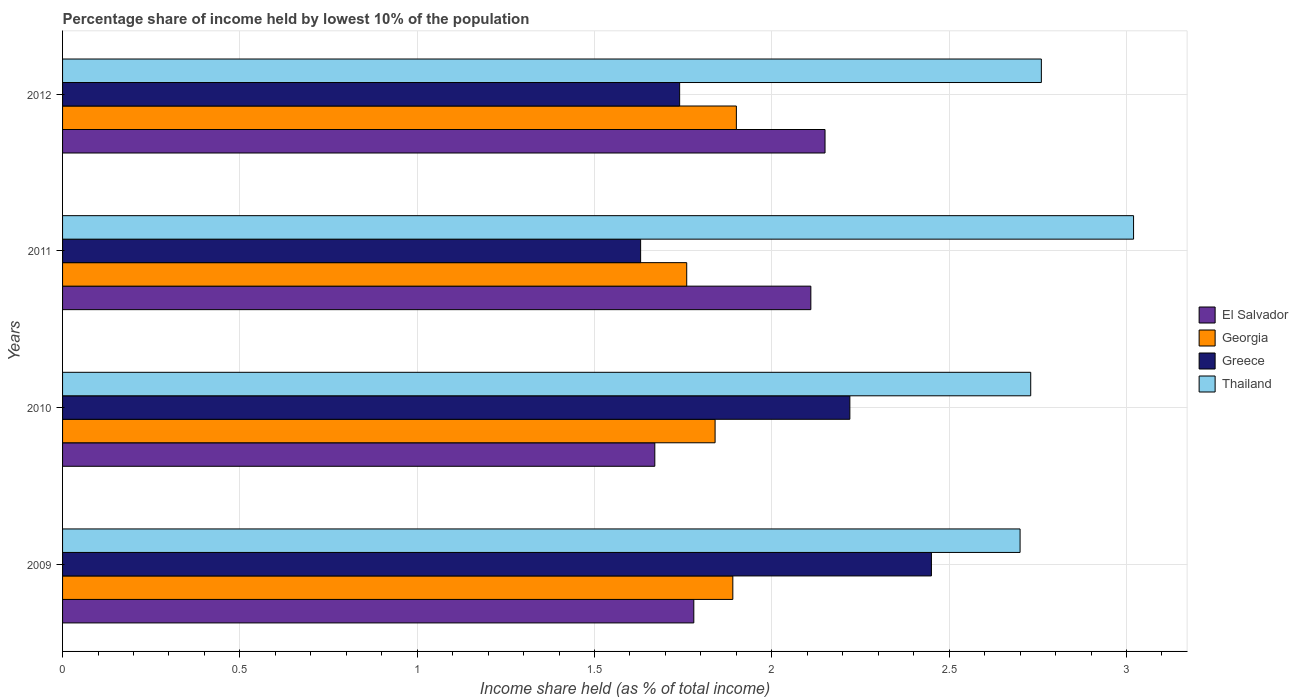How many groups of bars are there?
Your response must be concise. 4. Are the number of bars per tick equal to the number of legend labels?
Ensure brevity in your answer.  Yes. How many bars are there on the 1st tick from the top?
Offer a very short reply. 4. How many bars are there on the 4th tick from the bottom?
Offer a terse response. 4. In how many cases, is the number of bars for a given year not equal to the number of legend labels?
Give a very brief answer. 0. What is the percentage share of income held by lowest 10% of the population in Georgia in 2012?
Give a very brief answer. 1.9. Across all years, what is the maximum percentage share of income held by lowest 10% of the population in Thailand?
Offer a very short reply. 3.02. Across all years, what is the minimum percentage share of income held by lowest 10% of the population in Georgia?
Provide a succinct answer. 1.76. In which year was the percentage share of income held by lowest 10% of the population in Thailand maximum?
Your answer should be very brief. 2011. What is the total percentage share of income held by lowest 10% of the population in Greece in the graph?
Provide a succinct answer. 8.04. What is the difference between the percentage share of income held by lowest 10% of the population in Georgia in 2010 and that in 2012?
Your answer should be compact. -0.06. What is the difference between the percentage share of income held by lowest 10% of the population in Georgia in 2010 and the percentage share of income held by lowest 10% of the population in Thailand in 2009?
Offer a very short reply. -0.86. What is the average percentage share of income held by lowest 10% of the population in Georgia per year?
Keep it short and to the point. 1.85. In the year 2010, what is the difference between the percentage share of income held by lowest 10% of the population in Greece and percentage share of income held by lowest 10% of the population in El Salvador?
Ensure brevity in your answer.  0.55. In how many years, is the percentage share of income held by lowest 10% of the population in Georgia greater than 0.7 %?
Give a very brief answer. 4. What is the ratio of the percentage share of income held by lowest 10% of the population in Thailand in 2010 to that in 2011?
Your answer should be very brief. 0.9. Is the percentage share of income held by lowest 10% of the population in El Salvador in 2009 less than that in 2011?
Offer a very short reply. Yes. Is the difference between the percentage share of income held by lowest 10% of the population in Greece in 2011 and 2012 greater than the difference between the percentage share of income held by lowest 10% of the population in El Salvador in 2011 and 2012?
Provide a succinct answer. No. What is the difference between the highest and the second highest percentage share of income held by lowest 10% of the population in Georgia?
Make the answer very short. 0.01. What is the difference between the highest and the lowest percentage share of income held by lowest 10% of the population in Greece?
Your answer should be compact. 0.82. Is the sum of the percentage share of income held by lowest 10% of the population in Thailand in 2009 and 2011 greater than the maximum percentage share of income held by lowest 10% of the population in El Salvador across all years?
Your answer should be compact. Yes. What does the 4th bar from the top in 2011 represents?
Give a very brief answer. El Salvador. What does the 3rd bar from the bottom in 2012 represents?
Your answer should be very brief. Greece. What is the difference between two consecutive major ticks on the X-axis?
Provide a short and direct response. 0.5. Are the values on the major ticks of X-axis written in scientific E-notation?
Make the answer very short. No. Does the graph contain any zero values?
Provide a succinct answer. No. Does the graph contain grids?
Provide a short and direct response. Yes. Where does the legend appear in the graph?
Offer a terse response. Center right. How are the legend labels stacked?
Your response must be concise. Vertical. What is the title of the graph?
Provide a succinct answer. Percentage share of income held by lowest 10% of the population. Does "Kazakhstan" appear as one of the legend labels in the graph?
Offer a terse response. No. What is the label or title of the X-axis?
Ensure brevity in your answer.  Income share held (as % of total income). What is the Income share held (as % of total income) in El Salvador in 2009?
Give a very brief answer. 1.78. What is the Income share held (as % of total income) of Georgia in 2009?
Your answer should be very brief. 1.89. What is the Income share held (as % of total income) of Greece in 2009?
Your answer should be compact. 2.45. What is the Income share held (as % of total income) of Thailand in 2009?
Offer a very short reply. 2.7. What is the Income share held (as % of total income) in El Salvador in 2010?
Offer a terse response. 1.67. What is the Income share held (as % of total income) of Georgia in 2010?
Give a very brief answer. 1.84. What is the Income share held (as % of total income) of Greece in 2010?
Offer a terse response. 2.22. What is the Income share held (as % of total income) in Thailand in 2010?
Make the answer very short. 2.73. What is the Income share held (as % of total income) in El Salvador in 2011?
Provide a short and direct response. 2.11. What is the Income share held (as % of total income) in Georgia in 2011?
Your response must be concise. 1.76. What is the Income share held (as % of total income) of Greece in 2011?
Provide a succinct answer. 1.63. What is the Income share held (as % of total income) in Thailand in 2011?
Your response must be concise. 3.02. What is the Income share held (as % of total income) in El Salvador in 2012?
Ensure brevity in your answer.  2.15. What is the Income share held (as % of total income) of Georgia in 2012?
Your answer should be very brief. 1.9. What is the Income share held (as % of total income) in Greece in 2012?
Offer a very short reply. 1.74. What is the Income share held (as % of total income) in Thailand in 2012?
Your answer should be very brief. 2.76. Across all years, what is the maximum Income share held (as % of total income) in El Salvador?
Offer a terse response. 2.15. Across all years, what is the maximum Income share held (as % of total income) of Greece?
Provide a short and direct response. 2.45. Across all years, what is the maximum Income share held (as % of total income) in Thailand?
Your response must be concise. 3.02. Across all years, what is the minimum Income share held (as % of total income) of El Salvador?
Ensure brevity in your answer.  1.67. Across all years, what is the minimum Income share held (as % of total income) in Georgia?
Your answer should be compact. 1.76. Across all years, what is the minimum Income share held (as % of total income) of Greece?
Offer a terse response. 1.63. What is the total Income share held (as % of total income) in El Salvador in the graph?
Offer a terse response. 7.71. What is the total Income share held (as % of total income) of Georgia in the graph?
Offer a very short reply. 7.39. What is the total Income share held (as % of total income) of Greece in the graph?
Provide a short and direct response. 8.04. What is the total Income share held (as % of total income) in Thailand in the graph?
Your response must be concise. 11.21. What is the difference between the Income share held (as % of total income) of El Salvador in 2009 and that in 2010?
Give a very brief answer. 0.11. What is the difference between the Income share held (as % of total income) in Greece in 2009 and that in 2010?
Give a very brief answer. 0.23. What is the difference between the Income share held (as % of total income) in Thailand in 2009 and that in 2010?
Provide a short and direct response. -0.03. What is the difference between the Income share held (as % of total income) in El Salvador in 2009 and that in 2011?
Your answer should be very brief. -0.33. What is the difference between the Income share held (as % of total income) in Georgia in 2009 and that in 2011?
Your answer should be compact. 0.13. What is the difference between the Income share held (as % of total income) in Greece in 2009 and that in 2011?
Provide a short and direct response. 0.82. What is the difference between the Income share held (as % of total income) in Thailand in 2009 and that in 2011?
Provide a short and direct response. -0.32. What is the difference between the Income share held (as % of total income) in El Salvador in 2009 and that in 2012?
Offer a terse response. -0.37. What is the difference between the Income share held (as % of total income) of Georgia in 2009 and that in 2012?
Make the answer very short. -0.01. What is the difference between the Income share held (as % of total income) in Greece in 2009 and that in 2012?
Your answer should be compact. 0.71. What is the difference between the Income share held (as % of total income) in Thailand in 2009 and that in 2012?
Your answer should be very brief. -0.06. What is the difference between the Income share held (as % of total income) of El Salvador in 2010 and that in 2011?
Offer a terse response. -0.44. What is the difference between the Income share held (as % of total income) of Georgia in 2010 and that in 2011?
Keep it short and to the point. 0.08. What is the difference between the Income share held (as % of total income) in Greece in 2010 and that in 2011?
Give a very brief answer. 0.59. What is the difference between the Income share held (as % of total income) of Thailand in 2010 and that in 2011?
Make the answer very short. -0.29. What is the difference between the Income share held (as % of total income) of El Salvador in 2010 and that in 2012?
Your response must be concise. -0.48. What is the difference between the Income share held (as % of total income) in Georgia in 2010 and that in 2012?
Offer a terse response. -0.06. What is the difference between the Income share held (as % of total income) in Greece in 2010 and that in 2012?
Offer a terse response. 0.48. What is the difference between the Income share held (as % of total income) of Thailand in 2010 and that in 2012?
Your response must be concise. -0.03. What is the difference between the Income share held (as % of total income) of El Salvador in 2011 and that in 2012?
Offer a very short reply. -0.04. What is the difference between the Income share held (as % of total income) in Georgia in 2011 and that in 2012?
Make the answer very short. -0.14. What is the difference between the Income share held (as % of total income) in Greece in 2011 and that in 2012?
Provide a short and direct response. -0.11. What is the difference between the Income share held (as % of total income) of Thailand in 2011 and that in 2012?
Your answer should be very brief. 0.26. What is the difference between the Income share held (as % of total income) in El Salvador in 2009 and the Income share held (as % of total income) in Georgia in 2010?
Your response must be concise. -0.06. What is the difference between the Income share held (as % of total income) in El Salvador in 2009 and the Income share held (as % of total income) in Greece in 2010?
Offer a terse response. -0.44. What is the difference between the Income share held (as % of total income) in El Salvador in 2009 and the Income share held (as % of total income) in Thailand in 2010?
Provide a succinct answer. -0.95. What is the difference between the Income share held (as % of total income) in Georgia in 2009 and the Income share held (as % of total income) in Greece in 2010?
Your answer should be very brief. -0.33. What is the difference between the Income share held (as % of total income) of Georgia in 2009 and the Income share held (as % of total income) of Thailand in 2010?
Provide a short and direct response. -0.84. What is the difference between the Income share held (as % of total income) of Greece in 2009 and the Income share held (as % of total income) of Thailand in 2010?
Ensure brevity in your answer.  -0.28. What is the difference between the Income share held (as % of total income) of El Salvador in 2009 and the Income share held (as % of total income) of Greece in 2011?
Offer a terse response. 0.15. What is the difference between the Income share held (as % of total income) of El Salvador in 2009 and the Income share held (as % of total income) of Thailand in 2011?
Offer a terse response. -1.24. What is the difference between the Income share held (as % of total income) of Georgia in 2009 and the Income share held (as % of total income) of Greece in 2011?
Your answer should be compact. 0.26. What is the difference between the Income share held (as % of total income) of Georgia in 2009 and the Income share held (as % of total income) of Thailand in 2011?
Offer a very short reply. -1.13. What is the difference between the Income share held (as % of total income) in Greece in 2009 and the Income share held (as % of total income) in Thailand in 2011?
Keep it short and to the point. -0.57. What is the difference between the Income share held (as % of total income) in El Salvador in 2009 and the Income share held (as % of total income) in Georgia in 2012?
Your answer should be compact. -0.12. What is the difference between the Income share held (as % of total income) in El Salvador in 2009 and the Income share held (as % of total income) in Greece in 2012?
Offer a terse response. 0.04. What is the difference between the Income share held (as % of total income) of El Salvador in 2009 and the Income share held (as % of total income) of Thailand in 2012?
Offer a very short reply. -0.98. What is the difference between the Income share held (as % of total income) in Georgia in 2009 and the Income share held (as % of total income) in Greece in 2012?
Ensure brevity in your answer.  0.15. What is the difference between the Income share held (as % of total income) in Georgia in 2009 and the Income share held (as % of total income) in Thailand in 2012?
Your answer should be very brief. -0.87. What is the difference between the Income share held (as % of total income) in Greece in 2009 and the Income share held (as % of total income) in Thailand in 2012?
Offer a very short reply. -0.31. What is the difference between the Income share held (as % of total income) in El Salvador in 2010 and the Income share held (as % of total income) in Georgia in 2011?
Provide a short and direct response. -0.09. What is the difference between the Income share held (as % of total income) in El Salvador in 2010 and the Income share held (as % of total income) in Thailand in 2011?
Your answer should be very brief. -1.35. What is the difference between the Income share held (as % of total income) in Georgia in 2010 and the Income share held (as % of total income) in Greece in 2011?
Your answer should be very brief. 0.21. What is the difference between the Income share held (as % of total income) in Georgia in 2010 and the Income share held (as % of total income) in Thailand in 2011?
Provide a short and direct response. -1.18. What is the difference between the Income share held (as % of total income) of El Salvador in 2010 and the Income share held (as % of total income) of Georgia in 2012?
Offer a very short reply. -0.23. What is the difference between the Income share held (as % of total income) in El Salvador in 2010 and the Income share held (as % of total income) in Greece in 2012?
Provide a succinct answer. -0.07. What is the difference between the Income share held (as % of total income) of El Salvador in 2010 and the Income share held (as % of total income) of Thailand in 2012?
Your answer should be compact. -1.09. What is the difference between the Income share held (as % of total income) in Georgia in 2010 and the Income share held (as % of total income) in Thailand in 2012?
Your answer should be compact. -0.92. What is the difference between the Income share held (as % of total income) in Greece in 2010 and the Income share held (as % of total income) in Thailand in 2012?
Provide a short and direct response. -0.54. What is the difference between the Income share held (as % of total income) in El Salvador in 2011 and the Income share held (as % of total income) in Georgia in 2012?
Keep it short and to the point. 0.21. What is the difference between the Income share held (as % of total income) in El Salvador in 2011 and the Income share held (as % of total income) in Greece in 2012?
Your answer should be compact. 0.37. What is the difference between the Income share held (as % of total income) in El Salvador in 2011 and the Income share held (as % of total income) in Thailand in 2012?
Give a very brief answer. -0.65. What is the difference between the Income share held (as % of total income) in Georgia in 2011 and the Income share held (as % of total income) in Greece in 2012?
Your response must be concise. 0.02. What is the difference between the Income share held (as % of total income) of Georgia in 2011 and the Income share held (as % of total income) of Thailand in 2012?
Provide a short and direct response. -1. What is the difference between the Income share held (as % of total income) in Greece in 2011 and the Income share held (as % of total income) in Thailand in 2012?
Provide a succinct answer. -1.13. What is the average Income share held (as % of total income) of El Salvador per year?
Give a very brief answer. 1.93. What is the average Income share held (as % of total income) in Georgia per year?
Make the answer very short. 1.85. What is the average Income share held (as % of total income) in Greece per year?
Ensure brevity in your answer.  2.01. What is the average Income share held (as % of total income) of Thailand per year?
Offer a very short reply. 2.8. In the year 2009, what is the difference between the Income share held (as % of total income) of El Salvador and Income share held (as % of total income) of Georgia?
Keep it short and to the point. -0.11. In the year 2009, what is the difference between the Income share held (as % of total income) in El Salvador and Income share held (as % of total income) in Greece?
Your response must be concise. -0.67. In the year 2009, what is the difference between the Income share held (as % of total income) in El Salvador and Income share held (as % of total income) in Thailand?
Keep it short and to the point. -0.92. In the year 2009, what is the difference between the Income share held (as % of total income) of Georgia and Income share held (as % of total income) of Greece?
Provide a short and direct response. -0.56. In the year 2009, what is the difference between the Income share held (as % of total income) in Georgia and Income share held (as % of total income) in Thailand?
Offer a very short reply. -0.81. In the year 2009, what is the difference between the Income share held (as % of total income) of Greece and Income share held (as % of total income) of Thailand?
Give a very brief answer. -0.25. In the year 2010, what is the difference between the Income share held (as % of total income) in El Salvador and Income share held (as % of total income) in Georgia?
Your answer should be compact. -0.17. In the year 2010, what is the difference between the Income share held (as % of total income) in El Salvador and Income share held (as % of total income) in Greece?
Provide a succinct answer. -0.55. In the year 2010, what is the difference between the Income share held (as % of total income) in El Salvador and Income share held (as % of total income) in Thailand?
Offer a terse response. -1.06. In the year 2010, what is the difference between the Income share held (as % of total income) in Georgia and Income share held (as % of total income) in Greece?
Provide a succinct answer. -0.38. In the year 2010, what is the difference between the Income share held (as % of total income) of Georgia and Income share held (as % of total income) of Thailand?
Your answer should be very brief. -0.89. In the year 2010, what is the difference between the Income share held (as % of total income) in Greece and Income share held (as % of total income) in Thailand?
Your answer should be very brief. -0.51. In the year 2011, what is the difference between the Income share held (as % of total income) of El Salvador and Income share held (as % of total income) of Georgia?
Your answer should be compact. 0.35. In the year 2011, what is the difference between the Income share held (as % of total income) of El Salvador and Income share held (as % of total income) of Greece?
Provide a succinct answer. 0.48. In the year 2011, what is the difference between the Income share held (as % of total income) of El Salvador and Income share held (as % of total income) of Thailand?
Offer a very short reply. -0.91. In the year 2011, what is the difference between the Income share held (as % of total income) of Georgia and Income share held (as % of total income) of Greece?
Your response must be concise. 0.13. In the year 2011, what is the difference between the Income share held (as % of total income) in Georgia and Income share held (as % of total income) in Thailand?
Ensure brevity in your answer.  -1.26. In the year 2011, what is the difference between the Income share held (as % of total income) in Greece and Income share held (as % of total income) in Thailand?
Your answer should be compact. -1.39. In the year 2012, what is the difference between the Income share held (as % of total income) of El Salvador and Income share held (as % of total income) of Georgia?
Provide a short and direct response. 0.25. In the year 2012, what is the difference between the Income share held (as % of total income) of El Salvador and Income share held (as % of total income) of Greece?
Ensure brevity in your answer.  0.41. In the year 2012, what is the difference between the Income share held (as % of total income) of El Salvador and Income share held (as % of total income) of Thailand?
Keep it short and to the point. -0.61. In the year 2012, what is the difference between the Income share held (as % of total income) of Georgia and Income share held (as % of total income) of Greece?
Make the answer very short. 0.16. In the year 2012, what is the difference between the Income share held (as % of total income) of Georgia and Income share held (as % of total income) of Thailand?
Offer a very short reply. -0.86. In the year 2012, what is the difference between the Income share held (as % of total income) of Greece and Income share held (as % of total income) of Thailand?
Provide a succinct answer. -1.02. What is the ratio of the Income share held (as % of total income) of El Salvador in 2009 to that in 2010?
Ensure brevity in your answer.  1.07. What is the ratio of the Income share held (as % of total income) of Georgia in 2009 to that in 2010?
Offer a very short reply. 1.03. What is the ratio of the Income share held (as % of total income) of Greece in 2009 to that in 2010?
Provide a short and direct response. 1.1. What is the ratio of the Income share held (as % of total income) of El Salvador in 2009 to that in 2011?
Keep it short and to the point. 0.84. What is the ratio of the Income share held (as % of total income) of Georgia in 2009 to that in 2011?
Your answer should be compact. 1.07. What is the ratio of the Income share held (as % of total income) of Greece in 2009 to that in 2011?
Your response must be concise. 1.5. What is the ratio of the Income share held (as % of total income) in Thailand in 2009 to that in 2011?
Offer a very short reply. 0.89. What is the ratio of the Income share held (as % of total income) of El Salvador in 2009 to that in 2012?
Provide a succinct answer. 0.83. What is the ratio of the Income share held (as % of total income) in Georgia in 2009 to that in 2012?
Offer a terse response. 0.99. What is the ratio of the Income share held (as % of total income) of Greece in 2009 to that in 2012?
Provide a short and direct response. 1.41. What is the ratio of the Income share held (as % of total income) of Thailand in 2009 to that in 2012?
Your answer should be very brief. 0.98. What is the ratio of the Income share held (as % of total income) of El Salvador in 2010 to that in 2011?
Your answer should be compact. 0.79. What is the ratio of the Income share held (as % of total income) in Georgia in 2010 to that in 2011?
Your answer should be compact. 1.05. What is the ratio of the Income share held (as % of total income) in Greece in 2010 to that in 2011?
Provide a short and direct response. 1.36. What is the ratio of the Income share held (as % of total income) in Thailand in 2010 to that in 2011?
Your response must be concise. 0.9. What is the ratio of the Income share held (as % of total income) in El Salvador in 2010 to that in 2012?
Provide a short and direct response. 0.78. What is the ratio of the Income share held (as % of total income) in Georgia in 2010 to that in 2012?
Ensure brevity in your answer.  0.97. What is the ratio of the Income share held (as % of total income) in Greece in 2010 to that in 2012?
Make the answer very short. 1.28. What is the ratio of the Income share held (as % of total income) of El Salvador in 2011 to that in 2012?
Your answer should be very brief. 0.98. What is the ratio of the Income share held (as % of total income) of Georgia in 2011 to that in 2012?
Your answer should be very brief. 0.93. What is the ratio of the Income share held (as % of total income) in Greece in 2011 to that in 2012?
Provide a short and direct response. 0.94. What is the ratio of the Income share held (as % of total income) in Thailand in 2011 to that in 2012?
Your response must be concise. 1.09. What is the difference between the highest and the second highest Income share held (as % of total income) of Georgia?
Ensure brevity in your answer.  0.01. What is the difference between the highest and the second highest Income share held (as % of total income) of Greece?
Your response must be concise. 0.23. What is the difference between the highest and the second highest Income share held (as % of total income) of Thailand?
Your answer should be compact. 0.26. What is the difference between the highest and the lowest Income share held (as % of total income) of El Salvador?
Your answer should be very brief. 0.48. What is the difference between the highest and the lowest Income share held (as % of total income) of Georgia?
Keep it short and to the point. 0.14. What is the difference between the highest and the lowest Income share held (as % of total income) in Greece?
Your response must be concise. 0.82. What is the difference between the highest and the lowest Income share held (as % of total income) in Thailand?
Make the answer very short. 0.32. 